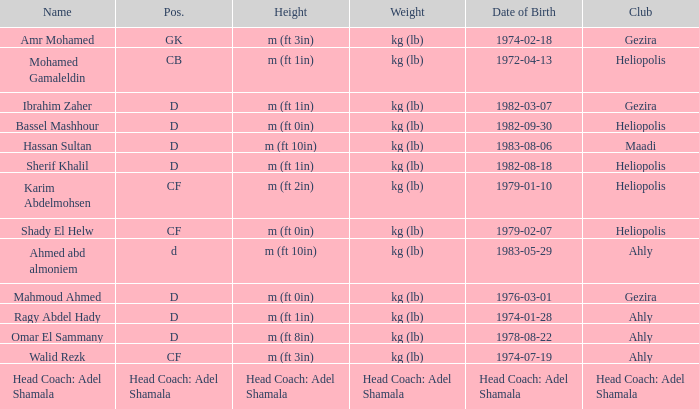What is Date of Birth, when Height is "Head Coach: Adel Shamala"? Head Coach: Adel Shamala. 